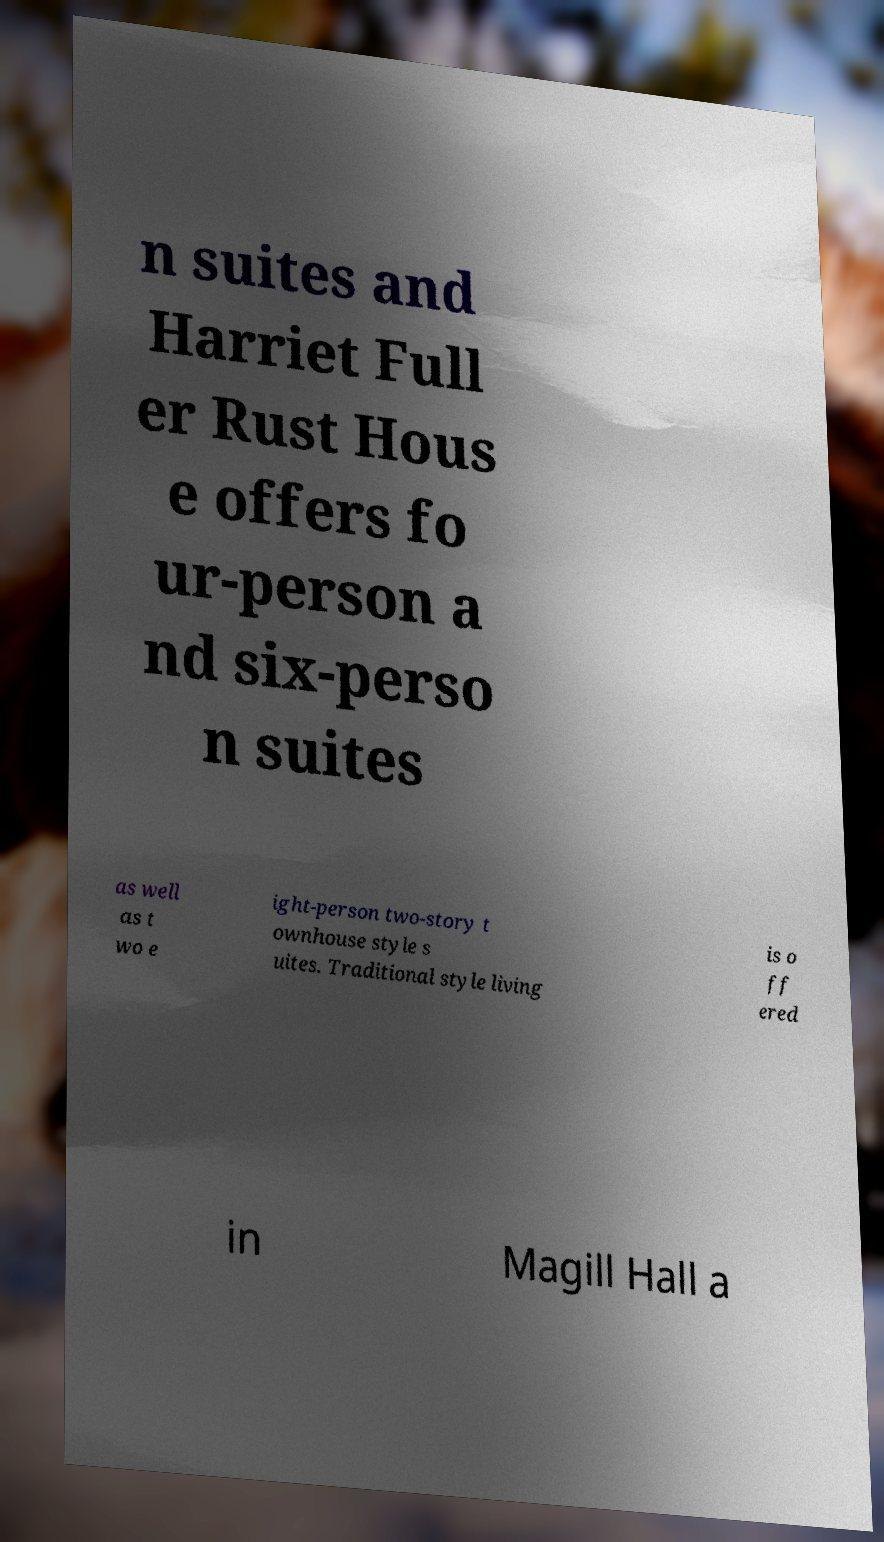What messages or text are displayed in this image? I need them in a readable, typed format. n suites and Harriet Full er Rust Hous e offers fo ur-person a nd six-perso n suites as well as t wo e ight-person two-story t ownhouse style s uites. Traditional style living is o ff ered in Magill Hall a 